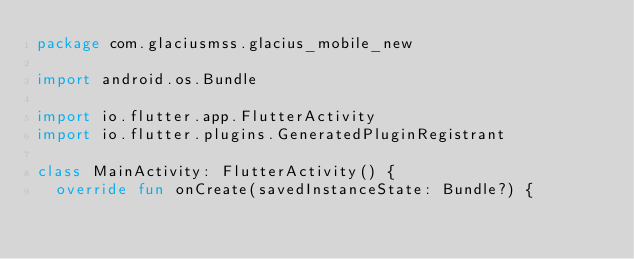Convert code to text. <code><loc_0><loc_0><loc_500><loc_500><_Kotlin_>package com.glaciusmss.glacius_mobile_new

import android.os.Bundle

import io.flutter.app.FlutterActivity
import io.flutter.plugins.GeneratedPluginRegistrant

class MainActivity: FlutterActivity() {
  override fun onCreate(savedInstanceState: Bundle?) {</code> 